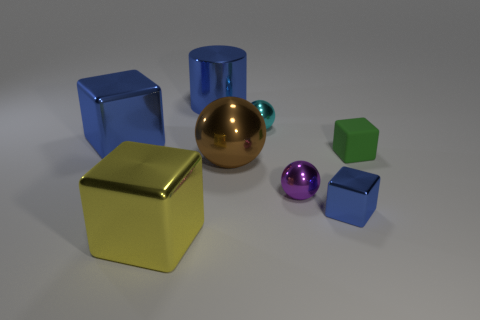Add 2 matte things. How many objects exist? 10 Subtract all balls. How many objects are left? 5 Subtract 0 cyan cylinders. How many objects are left? 8 Subtract all tiny green cubes. Subtract all large blue metal objects. How many objects are left? 5 Add 5 yellow metallic blocks. How many yellow metallic blocks are left? 6 Add 8 big purple cylinders. How many big purple cylinders exist? 8 